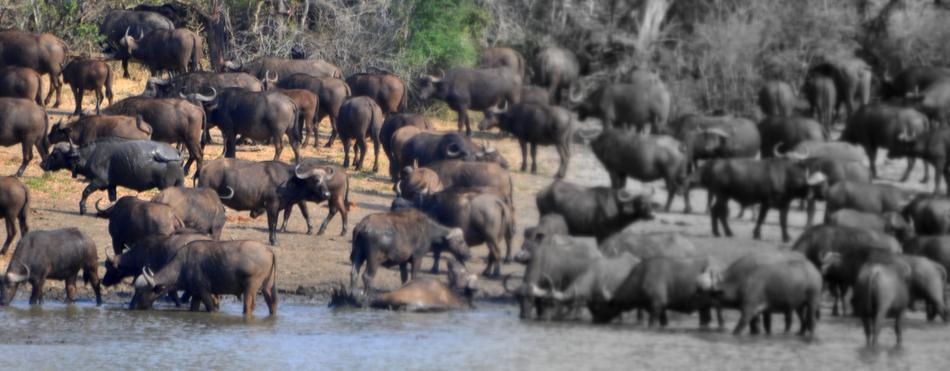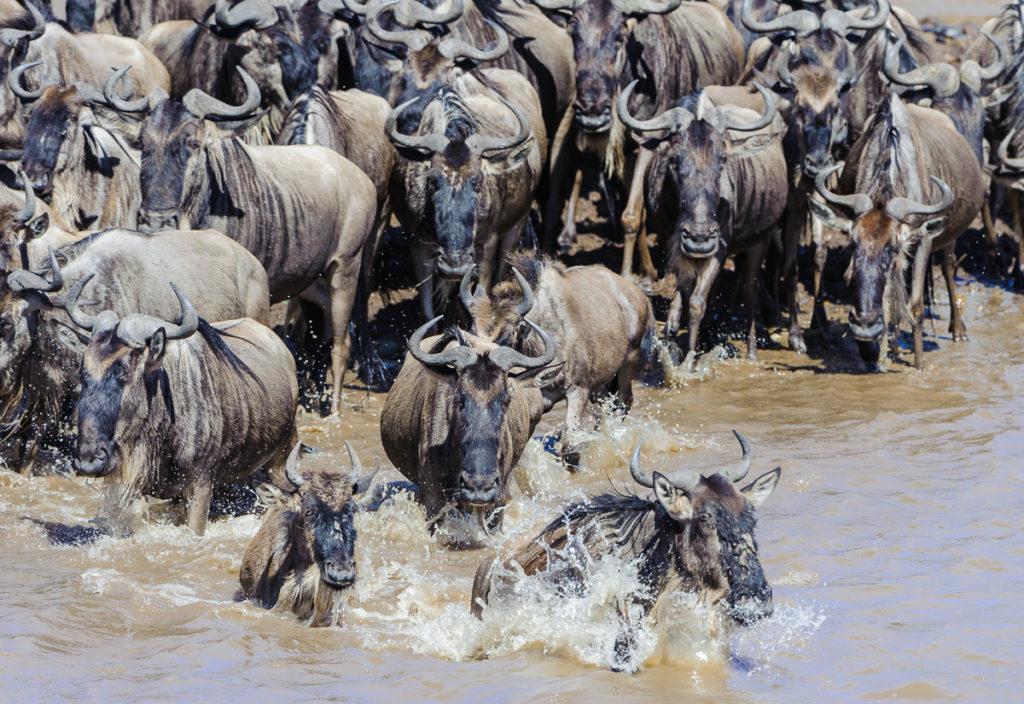The first image is the image on the left, the second image is the image on the right. Considering the images on both sides, is "there are animals in the water in the image on the right side" valid? Answer yes or no. Yes. The first image is the image on the left, the second image is the image on the right. Assess this claim about the two images: "All animals in the right image are on land.". Correct or not? Answer yes or no. No. 